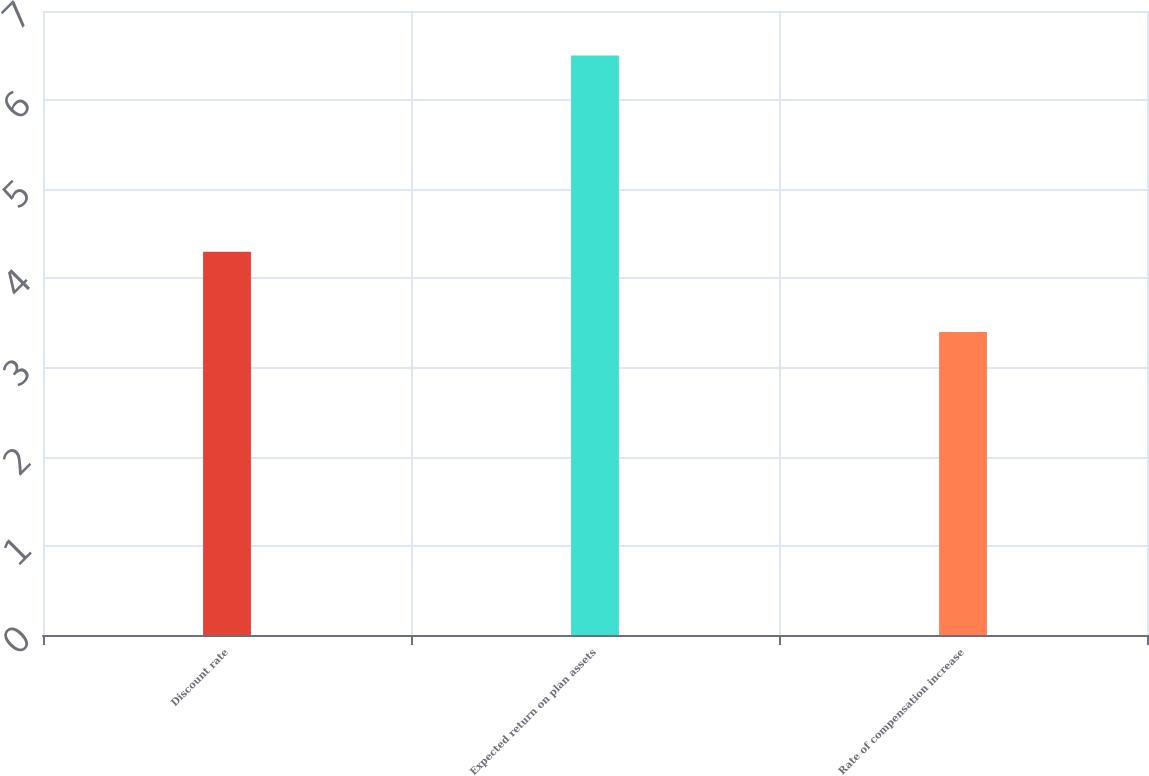<chart> <loc_0><loc_0><loc_500><loc_500><bar_chart><fcel>Discount rate<fcel>Expected return on plan assets<fcel>Rate of compensation increase<nl><fcel>4.3<fcel>6.5<fcel>3.4<nl></chart> 